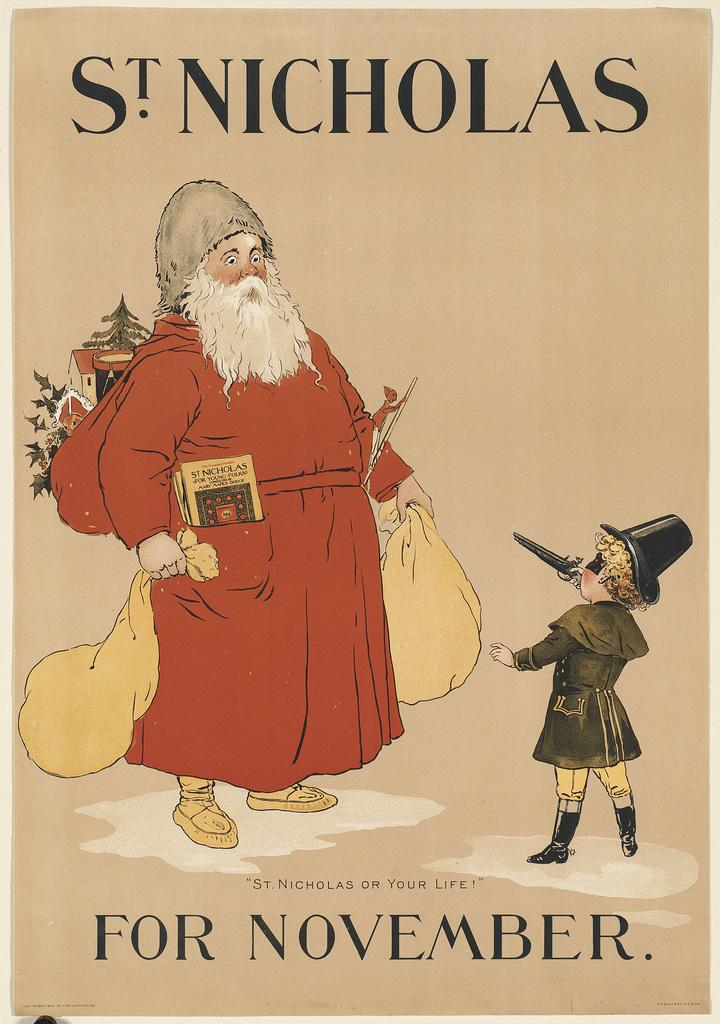What is the main subject of the image? The main subject of the image is a book. Can you tell me the title of the book? The name of the book is "St Nicholas for November." What can be seen on the cover page of the book? The cover page of the book features a Santa Claus and a kid. How many cows are visible on the cover page of the book? There are no cows visible on the cover page of the book; it features a Santa Claus and a kid. What type of calculator is used by the kid on the cover page of the book? There is no calculator present on the cover page of the book; it only features a Santa Claus and a kid. 